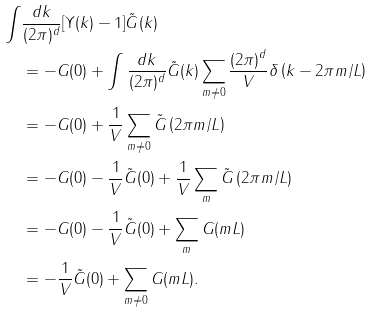Convert formula to latex. <formula><loc_0><loc_0><loc_500><loc_500>\int & \frac { d k } { ( 2 \pi ) ^ { d } } [ \Upsilon ( k ) - 1 ] \tilde { G } ( k ) \\ & = - G ( 0 ) + \int \frac { d k } { ( 2 \pi ) ^ { d } } \tilde { G } ( k ) \sum _ { m \neq 0 } \frac { ( 2 \pi ) ^ { d } } { V } \delta \left ( k - 2 \pi m / L \right ) \\ & = - G ( 0 ) + \frac { 1 } { V } \sum _ { m \neq 0 } \tilde { G } \left ( 2 \pi m / L \right ) \\ & = - G ( 0 ) - \frac { 1 } { V } \tilde { G } ( 0 ) + \frac { 1 } { V } \sum _ { m } \tilde { G } \left ( 2 \pi m / L \right ) \\ & = - G ( 0 ) - \frac { 1 } { V } \tilde { G } ( 0 ) + \sum _ { m } G ( m L ) \\ & = - \frac { 1 } { V } \tilde { G } ( 0 ) + \sum _ { m \neq 0 } G ( m L ) .</formula> 